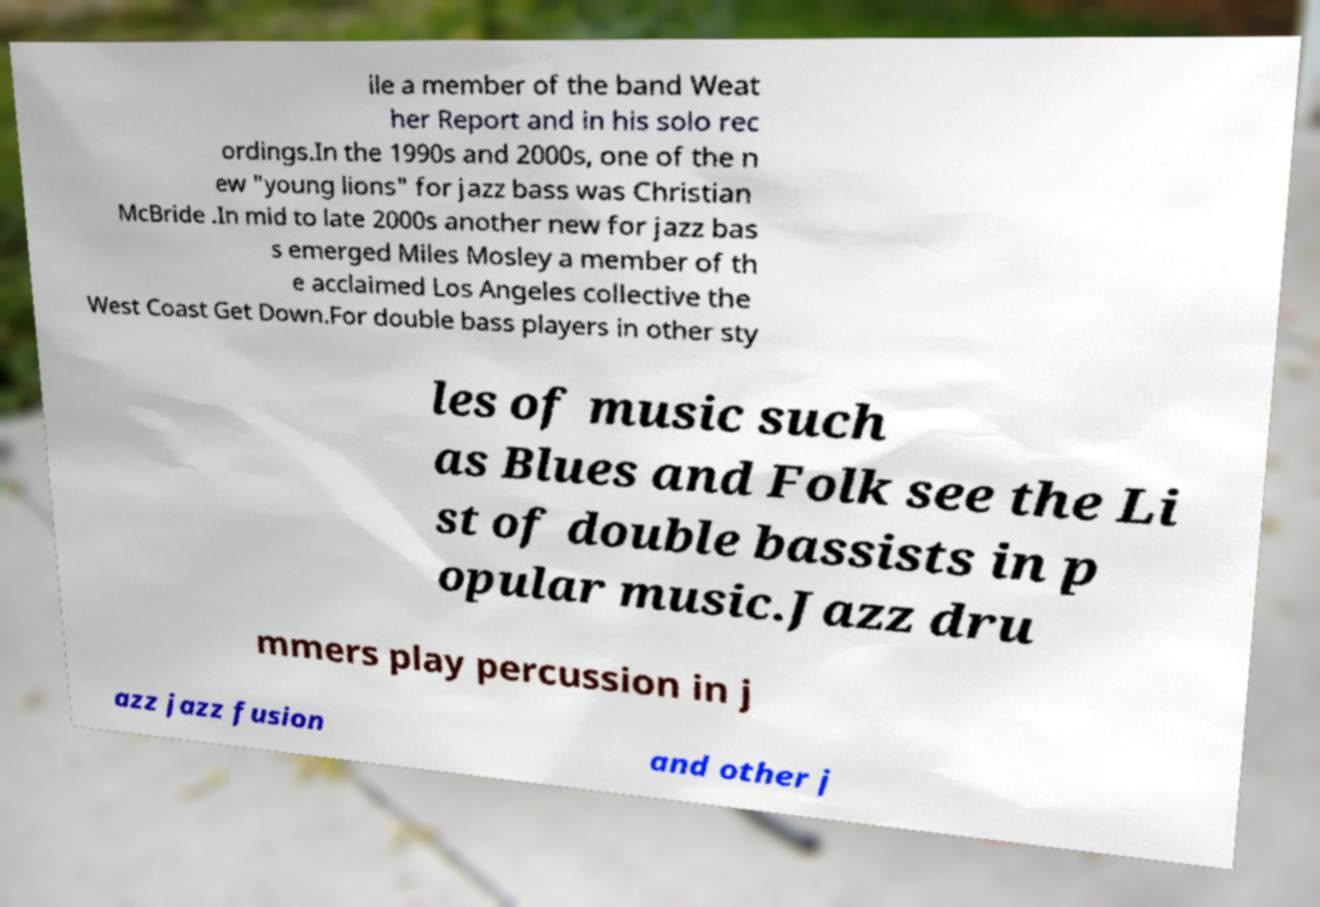For documentation purposes, I need the text within this image transcribed. Could you provide that? ile a member of the band Weat her Report and in his solo rec ordings.In the 1990s and 2000s, one of the n ew "young lions" for jazz bass was Christian McBride .In mid to late 2000s another new for jazz bas s emerged Miles Mosley a member of th e acclaimed Los Angeles collective the West Coast Get Down.For double bass players in other sty les of music such as Blues and Folk see the Li st of double bassists in p opular music.Jazz dru mmers play percussion in j azz jazz fusion and other j 